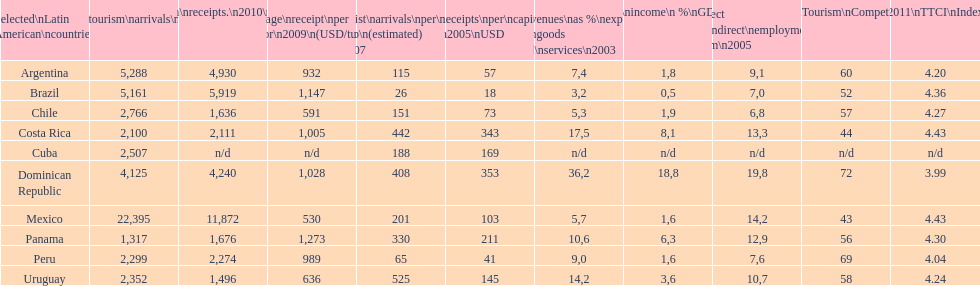Can you identify the last country displayed on this chart? Uruguay. 